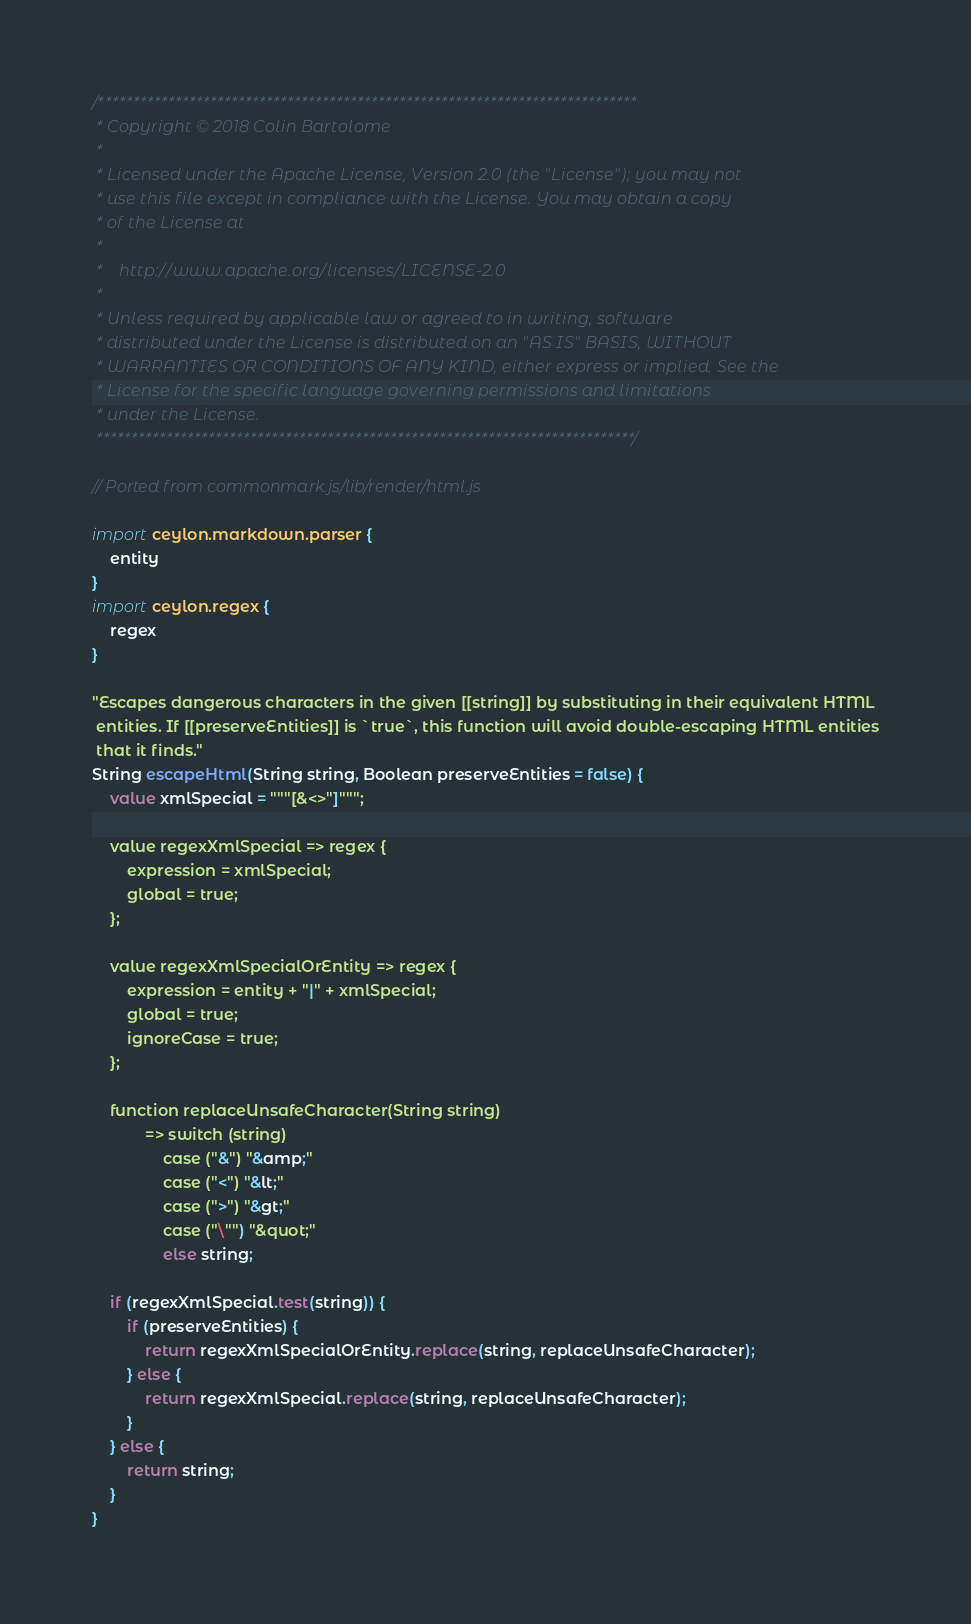Convert code to text. <code><loc_0><loc_0><loc_500><loc_500><_Ceylon_>/*****************************************************************************
 * Copyright © 2018 Colin Bartolome
 * 
 * Licensed under the Apache License, Version 2.0 (the "License"); you may not
 * use this file except in compliance with the License. You may obtain a copy
 * of the License at
 * 
 *    http://www.apache.org/licenses/LICENSE-2.0
 * 
 * Unless required by applicable law or agreed to in writing, software
 * distributed under the License is distributed on an "AS IS" BASIS, WITHOUT
 * WARRANTIES OR CONDITIONS OF ANY KIND, either express or implied. See the
 * License for the specific language governing permissions and limitations
 * under the License.
 *****************************************************************************/

// Ported from commonmark.js/lib/render/html.js

import ceylon.markdown.parser {
    entity
}
import ceylon.regex {
    regex
}

"Escapes dangerous characters in the given [[string]] by substituting in their equivalent HTML
 entities. If [[preserveEntities]] is `true`, this function will avoid double-escaping HTML entities
 that it finds."
String escapeHtml(String string, Boolean preserveEntities = false) {
    value xmlSpecial = """[&<>"]""";
    
    value regexXmlSpecial => regex {
        expression = xmlSpecial;
        global = true;
    };
    
    value regexXmlSpecialOrEntity => regex {
        expression = entity + "|" + xmlSpecial;
        global = true;
        ignoreCase = true;
    };
    
    function replaceUnsafeCharacter(String string)
            => switch (string)
                case ("&") "&amp;"
                case ("<") "&lt;"
                case (">") "&gt;"
                case ("\"") "&quot;"
                else string;
    
    if (regexXmlSpecial.test(string)) {
        if (preserveEntities) {
            return regexXmlSpecialOrEntity.replace(string, replaceUnsafeCharacter);
        } else {
            return regexXmlSpecial.replace(string, replaceUnsafeCharacter);
        }
    } else {
        return string;
    }
}
</code> 